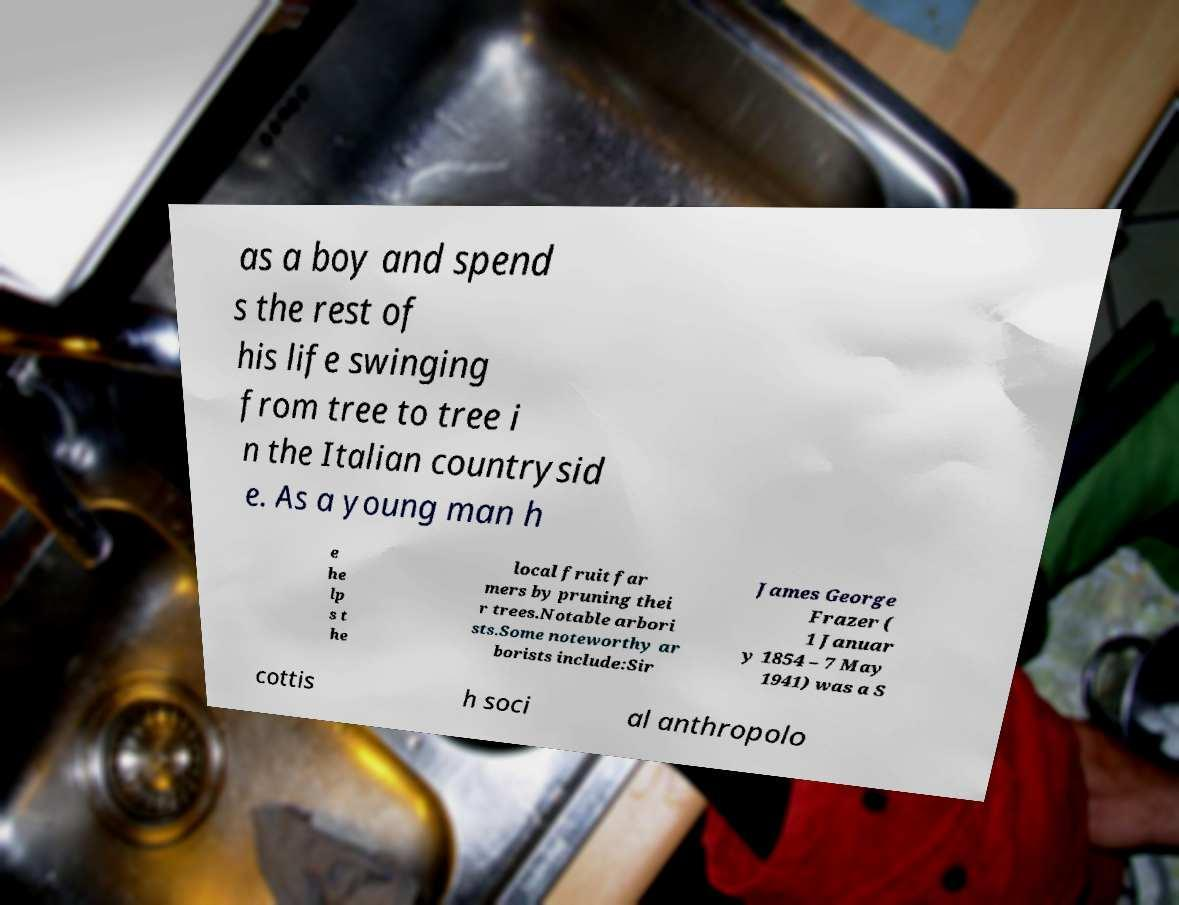Could you assist in decoding the text presented in this image and type it out clearly? as a boy and spend s the rest of his life swinging from tree to tree i n the Italian countrysid e. As a young man h e he lp s t he local fruit far mers by pruning thei r trees.Notable arbori sts.Some noteworthy ar borists include:Sir James George Frazer ( 1 Januar y 1854 – 7 May 1941) was a S cottis h soci al anthropolo 